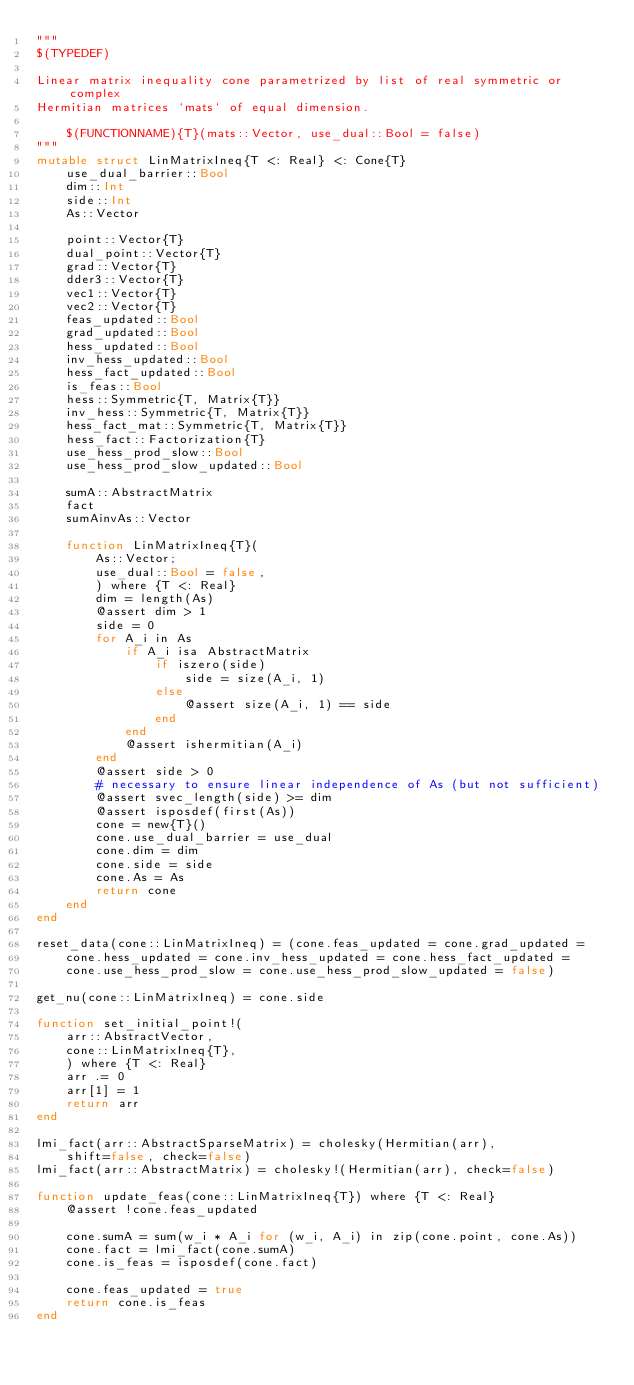Convert code to text. <code><loc_0><loc_0><loc_500><loc_500><_Julia_>"""
$(TYPEDEF)

Linear matrix inequality cone parametrized by list of real symmetric or complex
Hermitian matrices `mats` of equal dimension.

    $(FUNCTIONNAME){T}(mats::Vector, use_dual::Bool = false)
"""
mutable struct LinMatrixIneq{T <: Real} <: Cone{T}
    use_dual_barrier::Bool
    dim::Int
    side::Int
    As::Vector

    point::Vector{T}
    dual_point::Vector{T}
    grad::Vector{T}
    dder3::Vector{T}
    vec1::Vector{T}
    vec2::Vector{T}
    feas_updated::Bool
    grad_updated::Bool
    hess_updated::Bool
    inv_hess_updated::Bool
    hess_fact_updated::Bool
    is_feas::Bool
    hess::Symmetric{T, Matrix{T}}
    inv_hess::Symmetric{T, Matrix{T}}
    hess_fact_mat::Symmetric{T, Matrix{T}}
    hess_fact::Factorization{T}
    use_hess_prod_slow::Bool
    use_hess_prod_slow_updated::Bool

    sumA::AbstractMatrix
    fact
    sumAinvAs::Vector

    function LinMatrixIneq{T}(
        As::Vector;
        use_dual::Bool = false,
        ) where {T <: Real}
        dim = length(As)
        @assert dim > 1
        side = 0
        for A_i in As
            if A_i isa AbstractMatrix
                if iszero(side)
                    side = size(A_i, 1)
                else
                    @assert size(A_i, 1) == side
                end
            end
            @assert ishermitian(A_i)
        end
        @assert side > 0
        # necessary to ensure linear independence of As (but not sufficient)
        @assert svec_length(side) >= dim
        @assert isposdef(first(As))
        cone = new{T}()
        cone.use_dual_barrier = use_dual
        cone.dim = dim
        cone.side = side
        cone.As = As
        return cone
    end
end

reset_data(cone::LinMatrixIneq) = (cone.feas_updated = cone.grad_updated =
    cone.hess_updated = cone.inv_hess_updated = cone.hess_fact_updated =
    cone.use_hess_prod_slow = cone.use_hess_prod_slow_updated = false)

get_nu(cone::LinMatrixIneq) = cone.side

function set_initial_point!(
    arr::AbstractVector,
    cone::LinMatrixIneq{T},
    ) where {T <: Real}
    arr .= 0
    arr[1] = 1
    return arr
end

lmi_fact(arr::AbstractSparseMatrix) = cholesky(Hermitian(arr),
    shift=false, check=false)
lmi_fact(arr::AbstractMatrix) = cholesky!(Hermitian(arr), check=false)

function update_feas(cone::LinMatrixIneq{T}) where {T <: Real}
    @assert !cone.feas_updated

    cone.sumA = sum(w_i * A_i for (w_i, A_i) in zip(cone.point, cone.As))
    cone.fact = lmi_fact(cone.sumA)
    cone.is_feas = isposdef(cone.fact)

    cone.feas_updated = true
    return cone.is_feas
end
</code> 